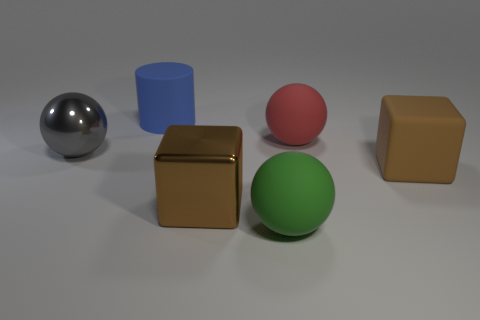Is the number of large matte cylinders to the right of the rubber cube the same as the number of large green matte balls?
Offer a very short reply. No. Does the large cylinder have the same color as the big metal block?
Provide a short and direct response. No. Does the big shiny thing in front of the big shiny ball have the same shape as the blue matte thing that is behind the green sphere?
Your answer should be compact. No. There is a large green object that is the same shape as the red rubber object; what is its material?
Your answer should be very brief. Rubber. There is a matte thing that is behind the large rubber cube and in front of the big blue thing; what color is it?
Your answer should be compact. Red. There is a cube that is right of the brown cube on the left side of the large green matte ball; are there any big rubber balls to the right of it?
Make the answer very short. No. What number of things are either red matte cubes or gray objects?
Offer a terse response. 1. Is the material of the blue cylinder the same as the big brown object that is in front of the big brown matte thing?
Your response must be concise. No. Is there any other thing of the same color as the big rubber block?
Keep it short and to the point. Yes. What number of objects are matte objects to the left of the metallic cube or rubber things in front of the blue cylinder?
Your answer should be very brief. 4. 